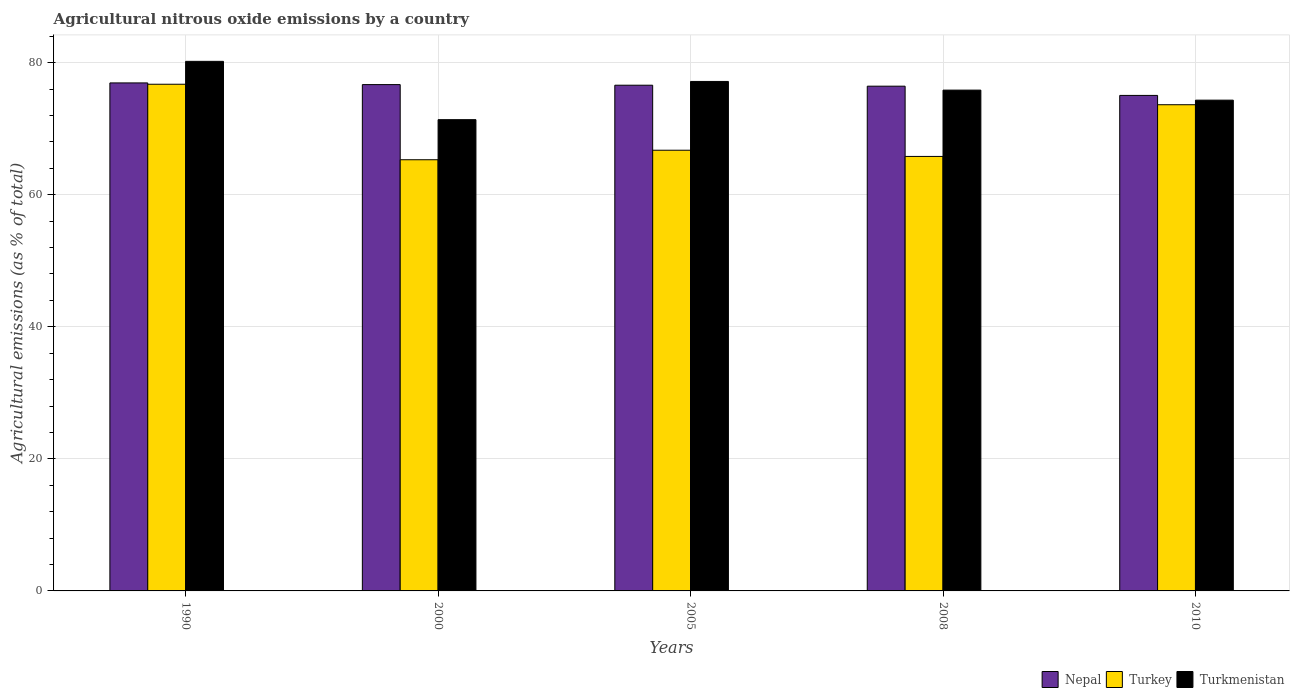How many different coloured bars are there?
Ensure brevity in your answer.  3. How many groups of bars are there?
Ensure brevity in your answer.  5. Are the number of bars on each tick of the X-axis equal?
Provide a short and direct response. Yes. What is the label of the 5th group of bars from the left?
Keep it short and to the point. 2010. In how many cases, is the number of bars for a given year not equal to the number of legend labels?
Your response must be concise. 0. What is the amount of agricultural nitrous oxide emitted in Turkmenistan in 2008?
Your response must be concise. 75.84. Across all years, what is the maximum amount of agricultural nitrous oxide emitted in Turkmenistan?
Ensure brevity in your answer.  80.2. Across all years, what is the minimum amount of agricultural nitrous oxide emitted in Turkmenistan?
Keep it short and to the point. 71.37. In which year was the amount of agricultural nitrous oxide emitted in Nepal maximum?
Your answer should be very brief. 1990. In which year was the amount of agricultural nitrous oxide emitted in Nepal minimum?
Make the answer very short. 2010. What is the total amount of agricultural nitrous oxide emitted in Turkmenistan in the graph?
Give a very brief answer. 378.89. What is the difference between the amount of agricultural nitrous oxide emitted in Turkmenistan in 1990 and that in 2005?
Your response must be concise. 3.04. What is the difference between the amount of agricultural nitrous oxide emitted in Turkey in 2000 and the amount of agricultural nitrous oxide emitted in Turkmenistan in 1990?
Provide a succinct answer. -14.9. What is the average amount of agricultural nitrous oxide emitted in Turkey per year?
Give a very brief answer. 69.64. In the year 2000, what is the difference between the amount of agricultural nitrous oxide emitted in Turkey and amount of agricultural nitrous oxide emitted in Turkmenistan?
Your answer should be very brief. -6.07. What is the ratio of the amount of agricultural nitrous oxide emitted in Turkmenistan in 1990 to that in 2010?
Provide a short and direct response. 1.08. Is the amount of agricultural nitrous oxide emitted in Nepal in 2005 less than that in 2010?
Offer a very short reply. No. Is the difference between the amount of agricultural nitrous oxide emitted in Turkey in 2000 and 2008 greater than the difference between the amount of agricultural nitrous oxide emitted in Turkmenistan in 2000 and 2008?
Offer a very short reply. Yes. What is the difference between the highest and the second highest amount of agricultural nitrous oxide emitted in Turkmenistan?
Your answer should be very brief. 3.04. What is the difference between the highest and the lowest amount of agricultural nitrous oxide emitted in Turkmenistan?
Your response must be concise. 8.83. In how many years, is the amount of agricultural nitrous oxide emitted in Turkey greater than the average amount of agricultural nitrous oxide emitted in Turkey taken over all years?
Provide a short and direct response. 2. Is the sum of the amount of agricultural nitrous oxide emitted in Turkey in 2008 and 2010 greater than the maximum amount of agricultural nitrous oxide emitted in Turkmenistan across all years?
Your answer should be very brief. Yes. What does the 3rd bar from the left in 1990 represents?
Provide a short and direct response. Turkmenistan. What does the 3rd bar from the right in 2010 represents?
Your answer should be very brief. Nepal. Is it the case that in every year, the sum of the amount of agricultural nitrous oxide emitted in Turkmenistan and amount of agricultural nitrous oxide emitted in Turkey is greater than the amount of agricultural nitrous oxide emitted in Nepal?
Give a very brief answer. Yes. How many bars are there?
Ensure brevity in your answer.  15. Are the values on the major ticks of Y-axis written in scientific E-notation?
Your answer should be compact. No. Where does the legend appear in the graph?
Provide a short and direct response. Bottom right. How many legend labels are there?
Your answer should be very brief. 3. What is the title of the graph?
Keep it short and to the point. Agricultural nitrous oxide emissions by a country. Does "Jordan" appear as one of the legend labels in the graph?
Your answer should be very brief. No. What is the label or title of the X-axis?
Make the answer very short. Years. What is the label or title of the Y-axis?
Ensure brevity in your answer.  Agricultural emissions (as % of total). What is the Agricultural emissions (as % of total) of Nepal in 1990?
Offer a very short reply. 76.93. What is the Agricultural emissions (as % of total) in Turkey in 1990?
Offer a terse response. 76.73. What is the Agricultural emissions (as % of total) of Turkmenistan in 1990?
Your answer should be very brief. 80.2. What is the Agricultural emissions (as % of total) in Nepal in 2000?
Your answer should be very brief. 76.68. What is the Agricultural emissions (as % of total) of Turkey in 2000?
Your answer should be compact. 65.3. What is the Agricultural emissions (as % of total) in Turkmenistan in 2000?
Ensure brevity in your answer.  71.37. What is the Agricultural emissions (as % of total) of Nepal in 2005?
Your answer should be compact. 76.59. What is the Agricultural emissions (as % of total) of Turkey in 2005?
Provide a short and direct response. 66.74. What is the Agricultural emissions (as % of total) in Turkmenistan in 2005?
Your response must be concise. 77.16. What is the Agricultural emissions (as % of total) of Nepal in 2008?
Give a very brief answer. 76.44. What is the Agricultural emissions (as % of total) in Turkey in 2008?
Provide a short and direct response. 65.8. What is the Agricultural emissions (as % of total) of Turkmenistan in 2008?
Provide a succinct answer. 75.84. What is the Agricultural emissions (as % of total) of Nepal in 2010?
Your answer should be very brief. 75.04. What is the Agricultural emissions (as % of total) in Turkey in 2010?
Keep it short and to the point. 73.63. What is the Agricultural emissions (as % of total) of Turkmenistan in 2010?
Provide a succinct answer. 74.32. Across all years, what is the maximum Agricultural emissions (as % of total) in Nepal?
Offer a terse response. 76.93. Across all years, what is the maximum Agricultural emissions (as % of total) of Turkey?
Provide a short and direct response. 76.73. Across all years, what is the maximum Agricultural emissions (as % of total) in Turkmenistan?
Give a very brief answer. 80.2. Across all years, what is the minimum Agricultural emissions (as % of total) in Nepal?
Provide a succinct answer. 75.04. Across all years, what is the minimum Agricultural emissions (as % of total) of Turkey?
Ensure brevity in your answer.  65.3. Across all years, what is the minimum Agricultural emissions (as % of total) in Turkmenistan?
Make the answer very short. 71.37. What is the total Agricultural emissions (as % of total) in Nepal in the graph?
Give a very brief answer. 381.68. What is the total Agricultural emissions (as % of total) in Turkey in the graph?
Your response must be concise. 348.2. What is the total Agricultural emissions (as % of total) in Turkmenistan in the graph?
Your response must be concise. 378.89. What is the difference between the Agricultural emissions (as % of total) in Nepal in 1990 and that in 2000?
Offer a terse response. 0.26. What is the difference between the Agricultural emissions (as % of total) of Turkey in 1990 and that in 2000?
Make the answer very short. 11.43. What is the difference between the Agricultural emissions (as % of total) in Turkmenistan in 1990 and that in 2000?
Offer a terse response. 8.83. What is the difference between the Agricultural emissions (as % of total) in Nepal in 1990 and that in 2005?
Offer a terse response. 0.35. What is the difference between the Agricultural emissions (as % of total) in Turkey in 1990 and that in 2005?
Offer a terse response. 9.99. What is the difference between the Agricultural emissions (as % of total) of Turkmenistan in 1990 and that in 2005?
Make the answer very short. 3.04. What is the difference between the Agricultural emissions (as % of total) in Nepal in 1990 and that in 2008?
Your response must be concise. 0.5. What is the difference between the Agricultural emissions (as % of total) of Turkey in 1990 and that in 2008?
Make the answer very short. 10.93. What is the difference between the Agricultural emissions (as % of total) of Turkmenistan in 1990 and that in 2008?
Provide a succinct answer. 4.36. What is the difference between the Agricultural emissions (as % of total) in Nepal in 1990 and that in 2010?
Ensure brevity in your answer.  1.89. What is the difference between the Agricultural emissions (as % of total) of Turkey in 1990 and that in 2010?
Keep it short and to the point. 3.1. What is the difference between the Agricultural emissions (as % of total) of Turkmenistan in 1990 and that in 2010?
Provide a succinct answer. 5.87. What is the difference between the Agricultural emissions (as % of total) of Nepal in 2000 and that in 2005?
Your answer should be very brief. 0.09. What is the difference between the Agricultural emissions (as % of total) in Turkey in 2000 and that in 2005?
Ensure brevity in your answer.  -1.44. What is the difference between the Agricultural emissions (as % of total) of Turkmenistan in 2000 and that in 2005?
Your answer should be very brief. -5.79. What is the difference between the Agricultural emissions (as % of total) of Nepal in 2000 and that in 2008?
Offer a terse response. 0.24. What is the difference between the Agricultural emissions (as % of total) in Turkey in 2000 and that in 2008?
Your response must be concise. -0.5. What is the difference between the Agricultural emissions (as % of total) of Turkmenistan in 2000 and that in 2008?
Your answer should be compact. -4.48. What is the difference between the Agricultural emissions (as % of total) of Nepal in 2000 and that in 2010?
Ensure brevity in your answer.  1.64. What is the difference between the Agricultural emissions (as % of total) of Turkey in 2000 and that in 2010?
Your answer should be compact. -8.33. What is the difference between the Agricultural emissions (as % of total) in Turkmenistan in 2000 and that in 2010?
Provide a short and direct response. -2.96. What is the difference between the Agricultural emissions (as % of total) in Nepal in 2005 and that in 2008?
Keep it short and to the point. 0.15. What is the difference between the Agricultural emissions (as % of total) in Turkey in 2005 and that in 2008?
Offer a terse response. 0.94. What is the difference between the Agricultural emissions (as % of total) of Turkmenistan in 2005 and that in 2008?
Provide a succinct answer. 1.31. What is the difference between the Agricultural emissions (as % of total) of Nepal in 2005 and that in 2010?
Provide a short and direct response. 1.55. What is the difference between the Agricultural emissions (as % of total) of Turkey in 2005 and that in 2010?
Your response must be concise. -6.89. What is the difference between the Agricultural emissions (as % of total) of Turkmenistan in 2005 and that in 2010?
Give a very brief answer. 2.83. What is the difference between the Agricultural emissions (as % of total) of Nepal in 2008 and that in 2010?
Give a very brief answer. 1.4. What is the difference between the Agricultural emissions (as % of total) in Turkey in 2008 and that in 2010?
Provide a short and direct response. -7.83. What is the difference between the Agricultural emissions (as % of total) in Turkmenistan in 2008 and that in 2010?
Make the answer very short. 1.52. What is the difference between the Agricultural emissions (as % of total) of Nepal in 1990 and the Agricultural emissions (as % of total) of Turkey in 2000?
Your answer should be compact. 11.64. What is the difference between the Agricultural emissions (as % of total) of Nepal in 1990 and the Agricultural emissions (as % of total) of Turkmenistan in 2000?
Provide a succinct answer. 5.57. What is the difference between the Agricultural emissions (as % of total) of Turkey in 1990 and the Agricultural emissions (as % of total) of Turkmenistan in 2000?
Your answer should be compact. 5.36. What is the difference between the Agricultural emissions (as % of total) of Nepal in 1990 and the Agricultural emissions (as % of total) of Turkey in 2005?
Provide a succinct answer. 10.19. What is the difference between the Agricultural emissions (as % of total) in Nepal in 1990 and the Agricultural emissions (as % of total) in Turkmenistan in 2005?
Your response must be concise. -0.22. What is the difference between the Agricultural emissions (as % of total) in Turkey in 1990 and the Agricultural emissions (as % of total) in Turkmenistan in 2005?
Offer a terse response. -0.42. What is the difference between the Agricultural emissions (as % of total) of Nepal in 1990 and the Agricultural emissions (as % of total) of Turkey in 2008?
Ensure brevity in your answer.  11.13. What is the difference between the Agricultural emissions (as % of total) of Nepal in 1990 and the Agricultural emissions (as % of total) of Turkmenistan in 2008?
Provide a succinct answer. 1.09. What is the difference between the Agricultural emissions (as % of total) of Turkey in 1990 and the Agricultural emissions (as % of total) of Turkmenistan in 2008?
Make the answer very short. 0.89. What is the difference between the Agricultural emissions (as % of total) in Nepal in 1990 and the Agricultural emissions (as % of total) in Turkey in 2010?
Make the answer very short. 3.3. What is the difference between the Agricultural emissions (as % of total) in Nepal in 1990 and the Agricultural emissions (as % of total) in Turkmenistan in 2010?
Offer a very short reply. 2.61. What is the difference between the Agricultural emissions (as % of total) of Turkey in 1990 and the Agricultural emissions (as % of total) of Turkmenistan in 2010?
Provide a short and direct response. 2.41. What is the difference between the Agricultural emissions (as % of total) in Nepal in 2000 and the Agricultural emissions (as % of total) in Turkey in 2005?
Give a very brief answer. 9.94. What is the difference between the Agricultural emissions (as % of total) of Nepal in 2000 and the Agricultural emissions (as % of total) of Turkmenistan in 2005?
Make the answer very short. -0.48. What is the difference between the Agricultural emissions (as % of total) of Turkey in 2000 and the Agricultural emissions (as % of total) of Turkmenistan in 2005?
Provide a short and direct response. -11.86. What is the difference between the Agricultural emissions (as % of total) of Nepal in 2000 and the Agricultural emissions (as % of total) of Turkey in 2008?
Your answer should be very brief. 10.88. What is the difference between the Agricultural emissions (as % of total) in Nepal in 2000 and the Agricultural emissions (as % of total) in Turkmenistan in 2008?
Make the answer very short. 0.83. What is the difference between the Agricultural emissions (as % of total) in Turkey in 2000 and the Agricultural emissions (as % of total) in Turkmenistan in 2008?
Give a very brief answer. -10.55. What is the difference between the Agricultural emissions (as % of total) in Nepal in 2000 and the Agricultural emissions (as % of total) in Turkey in 2010?
Your response must be concise. 3.05. What is the difference between the Agricultural emissions (as % of total) of Nepal in 2000 and the Agricultural emissions (as % of total) of Turkmenistan in 2010?
Your answer should be compact. 2.35. What is the difference between the Agricultural emissions (as % of total) of Turkey in 2000 and the Agricultural emissions (as % of total) of Turkmenistan in 2010?
Ensure brevity in your answer.  -9.03. What is the difference between the Agricultural emissions (as % of total) of Nepal in 2005 and the Agricultural emissions (as % of total) of Turkey in 2008?
Provide a succinct answer. 10.79. What is the difference between the Agricultural emissions (as % of total) of Nepal in 2005 and the Agricultural emissions (as % of total) of Turkmenistan in 2008?
Ensure brevity in your answer.  0.74. What is the difference between the Agricultural emissions (as % of total) of Turkey in 2005 and the Agricultural emissions (as % of total) of Turkmenistan in 2008?
Your response must be concise. -9.1. What is the difference between the Agricultural emissions (as % of total) in Nepal in 2005 and the Agricultural emissions (as % of total) in Turkey in 2010?
Your answer should be very brief. 2.96. What is the difference between the Agricultural emissions (as % of total) of Nepal in 2005 and the Agricultural emissions (as % of total) of Turkmenistan in 2010?
Provide a succinct answer. 2.26. What is the difference between the Agricultural emissions (as % of total) in Turkey in 2005 and the Agricultural emissions (as % of total) in Turkmenistan in 2010?
Your answer should be very brief. -7.58. What is the difference between the Agricultural emissions (as % of total) of Nepal in 2008 and the Agricultural emissions (as % of total) of Turkey in 2010?
Ensure brevity in your answer.  2.81. What is the difference between the Agricultural emissions (as % of total) of Nepal in 2008 and the Agricultural emissions (as % of total) of Turkmenistan in 2010?
Offer a very short reply. 2.11. What is the difference between the Agricultural emissions (as % of total) of Turkey in 2008 and the Agricultural emissions (as % of total) of Turkmenistan in 2010?
Your answer should be very brief. -8.52. What is the average Agricultural emissions (as % of total) of Nepal per year?
Keep it short and to the point. 76.34. What is the average Agricultural emissions (as % of total) of Turkey per year?
Give a very brief answer. 69.64. What is the average Agricultural emissions (as % of total) in Turkmenistan per year?
Your answer should be very brief. 75.78. In the year 1990, what is the difference between the Agricultural emissions (as % of total) in Nepal and Agricultural emissions (as % of total) in Turkey?
Provide a short and direct response. 0.2. In the year 1990, what is the difference between the Agricultural emissions (as % of total) in Nepal and Agricultural emissions (as % of total) in Turkmenistan?
Provide a succinct answer. -3.26. In the year 1990, what is the difference between the Agricultural emissions (as % of total) in Turkey and Agricultural emissions (as % of total) in Turkmenistan?
Ensure brevity in your answer.  -3.47. In the year 2000, what is the difference between the Agricultural emissions (as % of total) in Nepal and Agricultural emissions (as % of total) in Turkey?
Provide a succinct answer. 11.38. In the year 2000, what is the difference between the Agricultural emissions (as % of total) in Nepal and Agricultural emissions (as % of total) in Turkmenistan?
Your answer should be compact. 5.31. In the year 2000, what is the difference between the Agricultural emissions (as % of total) in Turkey and Agricultural emissions (as % of total) in Turkmenistan?
Ensure brevity in your answer.  -6.07. In the year 2005, what is the difference between the Agricultural emissions (as % of total) of Nepal and Agricultural emissions (as % of total) of Turkey?
Your response must be concise. 9.85. In the year 2005, what is the difference between the Agricultural emissions (as % of total) in Nepal and Agricultural emissions (as % of total) in Turkmenistan?
Ensure brevity in your answer.  -0.57. In the year 2005, what is the difference between the Agricultural emissions (as % of total) in Turkey and Agricultural emissions (as % of total) in Turkmenistan?
Your answer should be very brief. -10.42. In the year 2008, what is the difference between the Agricultural emissions (as % of total) of Nepal and Agricultural emissions (as % of total) of Turkey?
Offer a terse response. 10.64. In the year 2008, what is the difference between the Agricultural emissions (as % of total) of Nepal and Agricultural emissions (as % of total) of Turkmenistan?
Provide a short and direct response. 0.59. In the year 2008, what is the difference between the Agricultural emissions (as % of total) in Turkey and Agricultural emissions (as % of total) in Turkmenistan?
Offer a terse response. -10.04. In the year 2010, what is the difference between the Agricultural emissions (as % of total) in Nepal and Agricultural emissions (as % of total) in Turkey?
Provide a succinct answer. 1.41. In the year 2010, what is the difference between the Agricultural emissions (as % of total) in Nepal and Agricultural emissions (as % of total) in Turkmenistan?
Keep it short and to the point. 0.72. In the year 2010, what is the difference between the Agricultural emissions (as % of total) of Turkey and Agricultural emissions (as % of total) of Turkmenistan?
Ensure brevity in your answer.  -0.69. What is the ratio of the Agricultural emissions (as % of total) in Turkey in 1990 to that in 2000?
Keep it short and to the point. 1.18. What is the ratio of the Agricultural emissions (as % of total) in Turkmenistan in 1990 to that in 2000?
Make the answer very short. 1.12. What is the ratio of the Agricultural emissions (as % of total) of Nepal in 1990 to that in 2005?
Give a very brief answer. 1. What is the ratio of the Agricultural emissions (as % of total) of Turkey in 1990 to that in 2005?
Offer a very short reply. 1.15. What is the ratio of the Agricultural emissions (as % of total) in Turkmenistan in 1990 to that in 2005?
Offer a very short reply. 1.04. What is the ratio of the Agricultural emissions (as % of total) in Nepal in 1990 to that in 2008?
Give a very brief answer. 1.01. What is the ratio of the Agricultural emissions (as % of total) in Turkey in 1990 to that in 2008?
Make the answer very short. 1.17. What is the ratio of the Agricultural emissions (as % of total) of Turkmenistan in 1990 to that in 2008?
Give a very brief answer. 1.06. What is the ratio of the Agricultural emissions (as % of total) in Nepal in 1990 to that in 2010?
Your answer should be compact. 1.03. What is the ratio of the Agricultural emissions (as % of total) of Turkey in 1990 to that in 2010?
Provide a succinct answer. 1.04. What is the ratio of the Agricultural emissions (as % of total) of Turkmenistan in 1990 to that in 2010?
Offer a very short reply. 1.08. What is the ratio of the Agricultural emissions (as % of total) of Nepal in 2000 to that in 2005?
Give a very brief answer. 1. What is the ratio of the Agricultural emissions (as % of total) of Turkey in 2000 to that in 2005?
Provide a short and direct response. 0.98. What is the ratio of the Agricultural emissions (as % of total) of Turkmenistan in 2000 to that in 2005?
Provide a succinct answer. 0.93. What is the ratio of the Agricultural emissions (as % of total) of Turkmenistan in 2000 to that in 2008?
Give a very brief answer. 0.94. What is the ratio of the Agricultural emissions (as % of total) of Nepal in 2000 to that in 2010?
Make the answer very short. 1.02. What is the ratio of the Agricultural emissions (as % of total) of Turkey in 2000 to that in 2010?
Your response must be concise. 0.89. What is the ratio of the Agricultural emissions (as % of total) in Turkmenistan in 2000 to that in 2010?
Your answer should be compact. 0.96. What is the ratio of the Agricultural emissions (as % of total) in Nepal in 2005 to that in 2008?
Ensure brevity in your answer.  1. What is the ratio of the Agricultural emissions (as % of total) of Turkey in 2005 to that in 2008?
Offer a very short reply. 1.01. What is the ratio of the Agricultural emissions (as % of total) in Turkmenistan in 2005 to that in 2008?
Ensure brevity in your answer.  1.02. What is the ratio of the Agricultural emissions (as % of total) in Nepal in 2005 to that in 2010?
Keep it short and to the point. 1.02. What is the ratio of the Agricultural emissions (as % of total) in Turkey in 2005 to that in 2010?
Your answer should be compact. 0.91. What is the ratio of the Agricultural emissions (as % of total) of Turkmenistan in 2005 to that in 2010?
Offer a very short reply. 1.04. What is the ratio of the Agricultural emissions (as % of total) of Nepal in 2008 to that in 2010?
Keep it short and to the point. 1.02. What is the ratio of the Agricultural emissions (as % of total) in Turkey in 2008 to that in 2010?
Your answer should be compact. 0.89. What is the ratio of the Agricultural emissions (as % of total) of Turkmenistan in 2008 to that in 2010?
Ensure brevity in your answer.  1.02. What is the difference between the highest and the second highest Agricultural emissions (as % of total) of Nepal?
Keep it short and to the point. 0.26. What is the difference between the highest and the second highest Agricultural emissions (as % of total) of Turkey?
Your answer should be very brief. 3.1. What is the difference between the highest and the second highest Agricultural emissions (as % of total) of Turkmenistan?
Give a very brief answer. 3.04. What is the difference between the highest and the lowest Agricultural emissions (as % of total) of Nepal?
Offer a terse response. 1.89. What is the difference between the highest and the lowest Agricultural emissions (as % of total) in Turkey?
Keep it short and to the point. 11.43. What is the difference between the highest and the lowest Agricultural emissions (as % of total) in Turkmenistan?
Your response must be concise. 8.83. 